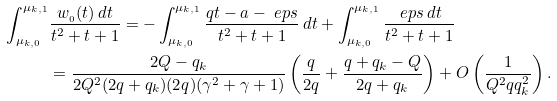<formula> <loc_0><loc_0><loc_500><loc_500>\int _ { \mu _ { k , 0 } } ^ { \mu _ { k , 1 } } & \frac { w _ { \AA _ { 0 } } ( t ) \, d t } { t ^ { 2 } + t + 1 } = - \int _ { \mu _ { k , 0 } } ^ { \mu _ { k , 1 } } \frac { q t - a - \ e p s } { t ^ { 2 } + t + 1 } \, d t + \int _ { \mu _ { k , 0 } } ^ { \mu _ { k , 1 } } \frac { \ e p s \, d t } { t ^ { 2 } + t + 1 } \\ & = \frac { 2 Q - q _ { k } } { 2 Q ^ { 2 } ( 2 q + q _ { k } ) ( 2 q ) ( \gamma ^ { 2 } + \gamma + 1 ) } \left ( \frac { q } { 2 q } + \frac { q + q _ { k } - Q } { 2 q + q _ { k } } \right ) + O \left ( \frac { 1 } { Q ^ { 2 } q q _ { k } ^ { 2 } } \right ) .</formula> 